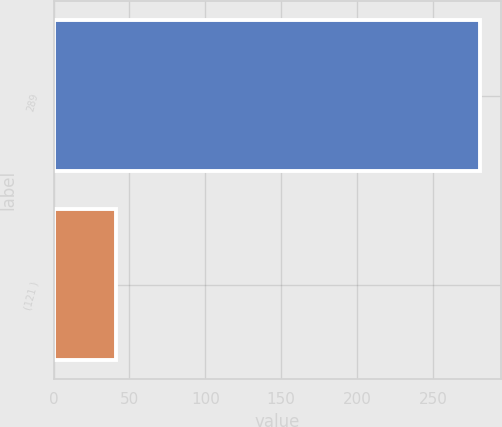Convert chart to OTSL. <chart><loc_0><loc_0><loc_500><loc_500><bar_chart><fcel>289<fcel>(121 )<nl><fcel>281<fcel>41<nl></chart> 